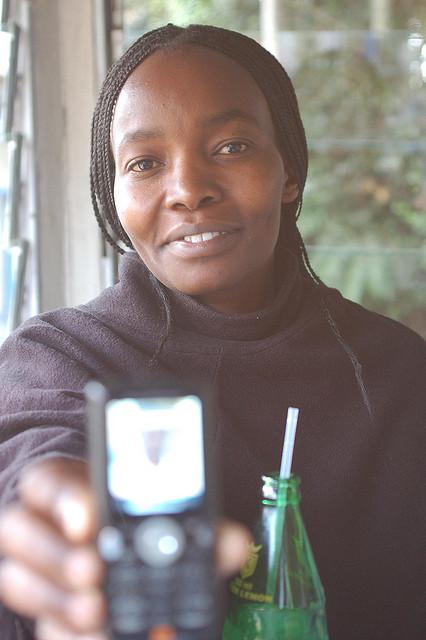What tool is she using to drink?
Write a very short answer. Straw. How is her hair styled?
Keep it brief. Braided. What is the person holding?
Give a very brief answer. Phone. Is she smiling?
Keep it brief. Yes. 